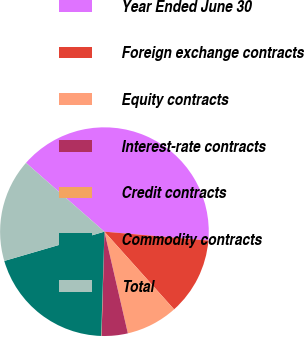Convert chart. <chart><loc_0><loc_0><loc_500><loc_500><pie_chart><fcel>Year Ended June 30<fcel>Foreign exchange contracts<fcel>Equity contracts<fcel>Interest-rate contracts<fcel>Credit contracts<fcel>Commodity contracts<fcel>Total<nl><fcel>39.89%<fcel>12.01%<fcel>8.03%<fcel>4.04%<fcel>0.06%<fcel>19.98%<fcel>15.99%<nl></chart> 